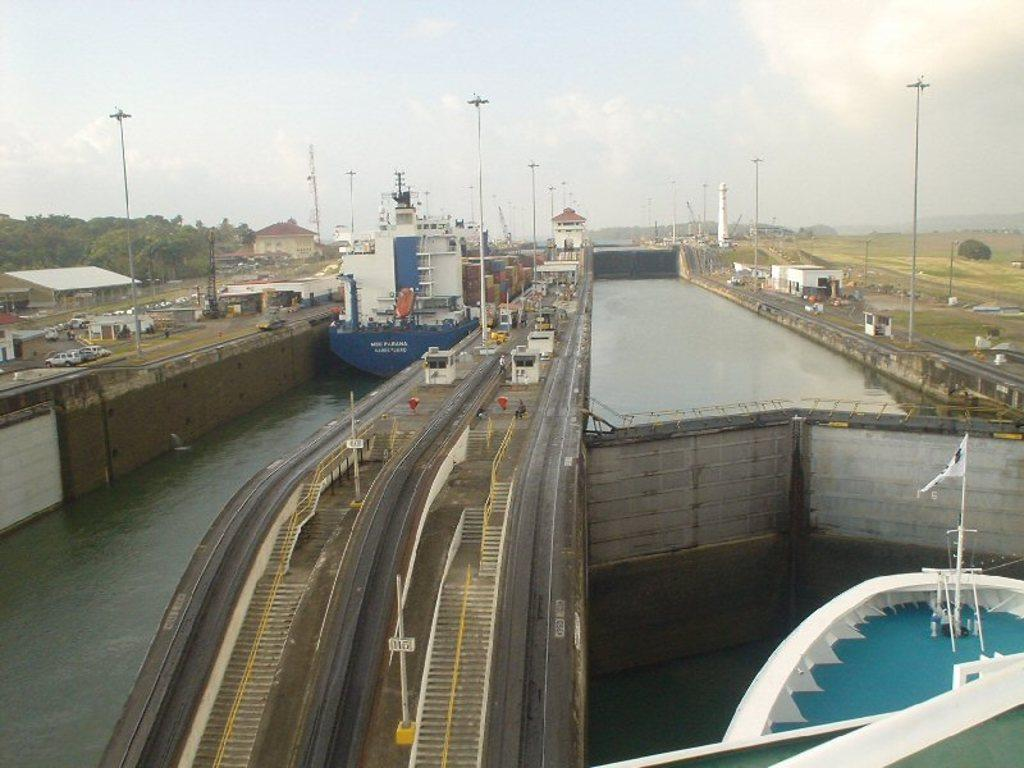What type of vehicles can be seen on the left side of the image? There are vehicles on the left side of the image, but the specific type is not mentioned in the facts. What is the primary setting of the image? The primary setting of the image includes water, ships, trees, buildings, and the sky. Can you describe the sky in the image? The sky is visible at the top of the image. What type of beef is being cooked on the trees in the image? There is no beef or cooking activity present in the image; it features ships, water, vehicles, trees, buildings, and the sky. What is the wish of the trees in the image? Trees do not have wishes, as they are inanimate objects. 